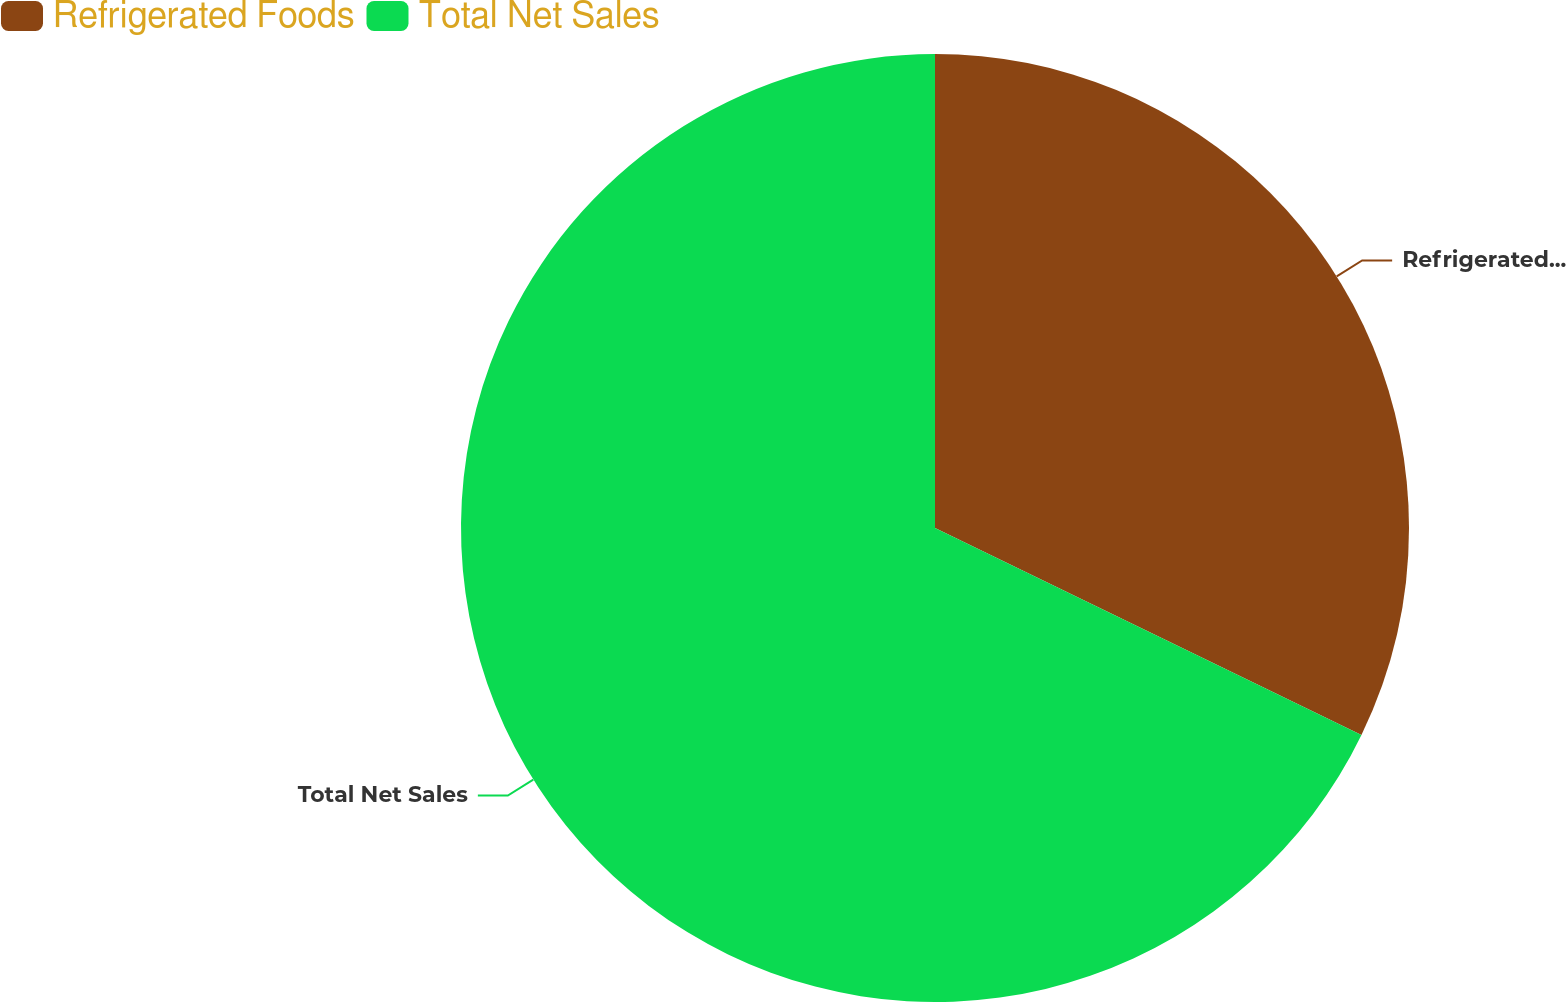Convert chart to OTSL. <chart><loc_0><loc_0><loc_500><loc_500><pie_chart><fcel>Refrigerated Foods<fcel>Total Net Sales<nl><fcel>32.19%<fcel>67.81%<nl></chart> 